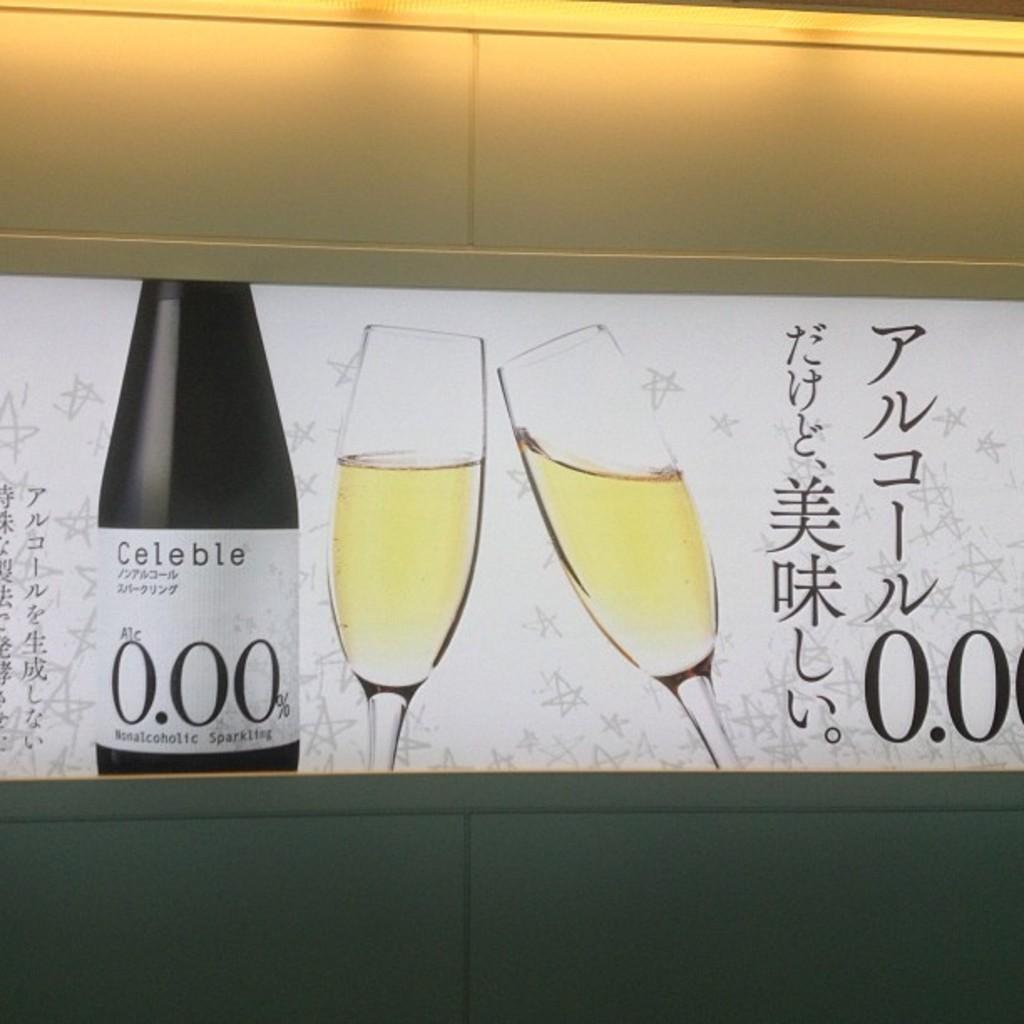What is featured on the poster in the image? The poster contains a bottle and glasses with a drink in them. What else can be seen on the poster? There is text on the poster. What is visible in the background of the image? There is a wall in the background of the image. What type of fiction is being read by the cabbage in the image? There is no cabbage or fiction present in the image; it features a poster with a bottle, glasses, and text. 